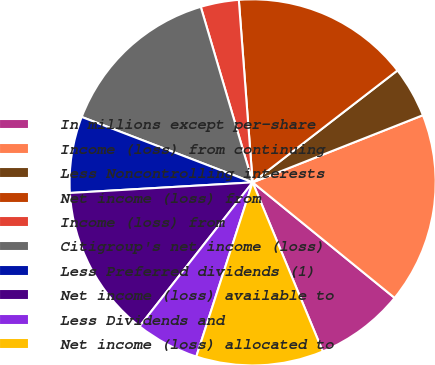Convert chart. <chart><loc_0><loc_0><loc_500><loc_500><pie_chart><fcel>In millions except per-share<fcel>Income (loss) from continuing<fcel>Less Noncontrolling interests<fcel>Net income (loss) from<fcel>Income (loss) from<fcel>Citigroup's net income (loss)<fcel>Less Preferred dividends (1)<fcel>Net income (loss) available to<fcel>Less Dividends and<fcel>Net income (loss) allocated to<nl><fcel>7.87%<fcel>16.85%<fcel>4.49%<fcel>15.73%<fcel>3.37%<fcel>14.61%<fcel>6.74%<fcel>13.48%<fcel>5.62%<fcel>11.24%<nl></chart> 